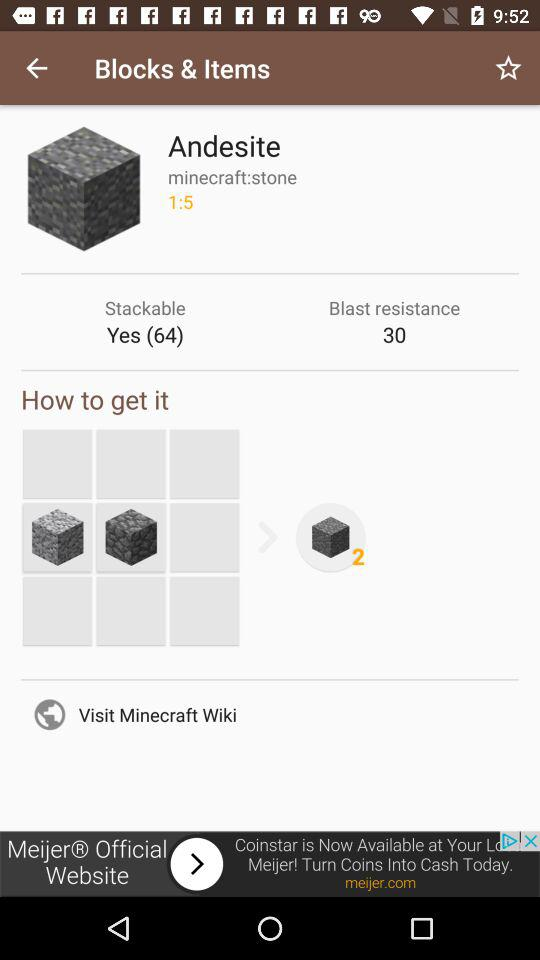What is the blast resistance? The blast resistance is 30. 